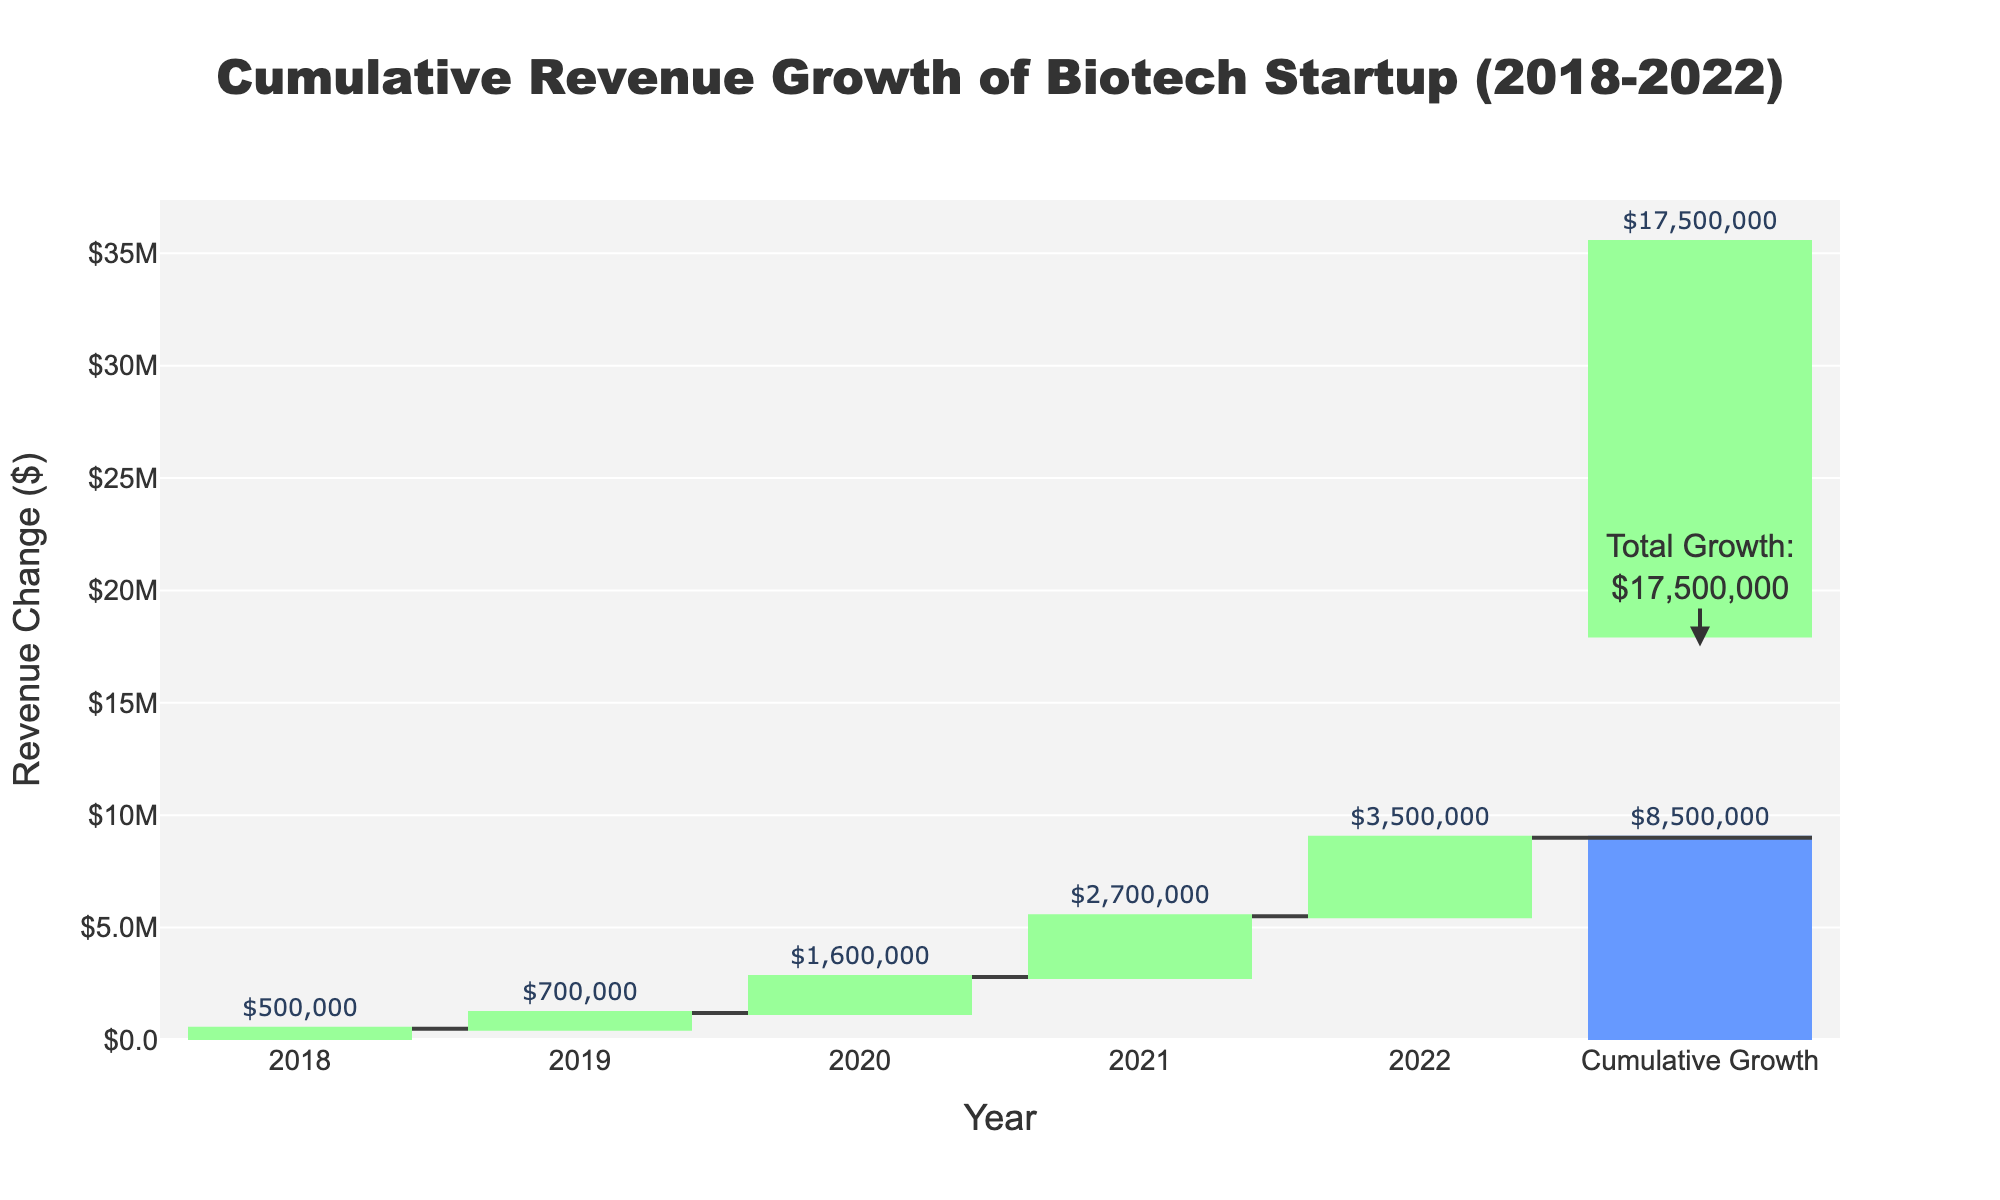What is the title of the chart? The title is displayed at the top of the chart.
Answer: Cumulative Revenue Growth of Biotech Startup (2018-2022) How many years of data are represented? The x-axis lists the years from 2018 to 2022, which indicates that there are 5 years plus the cumulative growth.
Answer: 5 years What is the revenue change in 2020? The waterfall chart shows a bar with the label for the year 2020. The text outside the bar shows the revenue change.
Answer: $1,600,000 What was the cumulative revenue growth by 2022? The cumulative growth bar at the end of the chart shows a text label outside, indicating the total revenue growth over the period.
Answer: $8,500,000 What was the lowest annual revenue change, and in what year did it occur? The smallest bar indicates the lowest revenue change. The smallest bar has the text "$500,000" and is labeled for the year 2018.
Answer: $500,000 in 2018 What is the difference in revenue change between 2021 and 2022? The revenue change for 2021 is $2,700,000 and for 2022 is $3,500,000. Subtract the earlier year from the later year: $3,500,000 - $2,700,000.
Answer: $800,000 Which year experienced the highest revenue change? The tallest bar represents the highest revenue change. The year 2022 has the tallest bar with a change of $3,500,000.
Answer: 2022 How much total revenue change occurred from 2018 to 2020? Add the revenue changes for 2018, 2019, and 2020: $500,000 + $700,000 + $1,600,000.
Answer: $2,800,000 Were there any years where the revenue change decreased compared to the previous year? Compare the heights of each year's bar to the previous year. Every year's bar is taller than the previous one, indicating no decrease.
Answer: No What is the average annual revenue change from 2018 to 2022? Sum the revenue changes and divide by the number of years. $500,000 + $700,000 + $1,600,000 + $2,700,000 + $3,500,000 = $9,000,000. Average = $9,000,000 / 5.
Answer: $1,800,000 